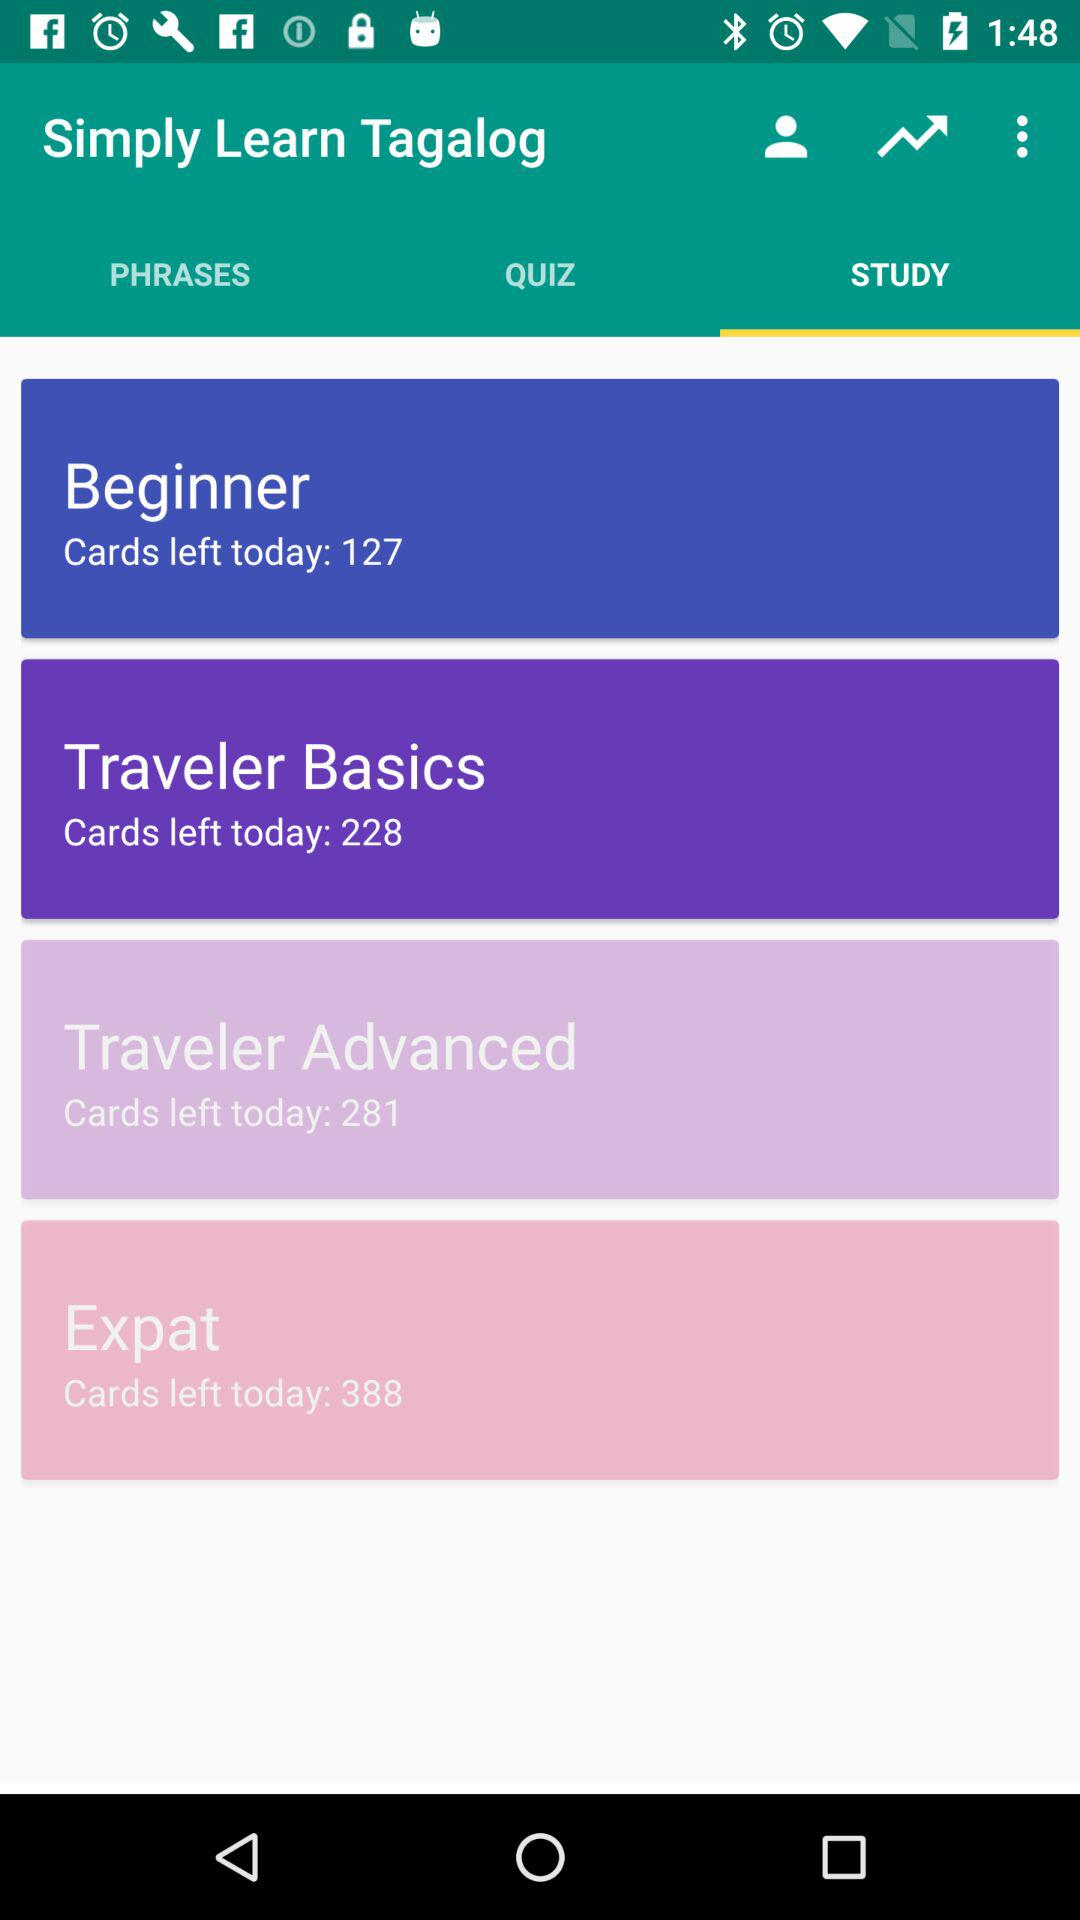Which tab am I using? You are using "STUDY" tab. 